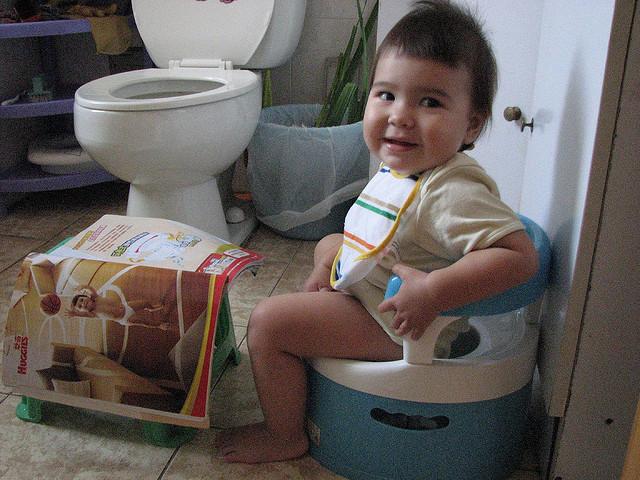What is the baby doing?
Short answer required. Going potty. Can his feet touch the ground?
Be succinct. Yes. Is there a plant in the picture?
Concise answer only. Yes. What is the garbage can liner made of?
Be succinct. Plastic. Does he have shoes on?
Keep it brief. No. Are the boy's hands empty?
Give a very brief answer. Yes. Is this person a grown up?
Quick response, please. No. What part of the newspaper is the baby looking at?
Short answer required. Ads. 